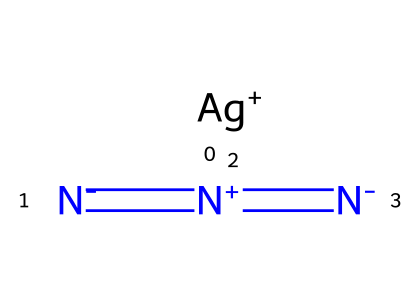What is the total number of nitrogen atoms in silver azide? The structure includes three nitrogen atoms in its formula. Each nitrogen atom is explicitly represented in the SMILES notation.
Answer: three How many bonds are present in the silver azide molecule? Analyzing the structure, there is one bond between silver and nitrogen, and two bonds between the nitrogen atoms. Adding these gives a total of three bonds.
Answer: three What is the primary function of silver azide in photographic film development? Silver azide acts as a light-sensitive compound, which is responsible for creating images in photographic processes.
Answer: light-sensitive Which type of chemical is silver azide classified as? Silver azide belongs to the azide family, characterized by the presence of the azide group (N3).
Answer: azide What charge does the silver ion carry in silver azide? The silver ion is represented as Ag+ in the structure, indicating that it has a positive charge.
Answer: positive What is the oxidation state of nitrogen in silver azide? The nitrogen atoms in the azide group typically have an average oxidation state of -1 each, as indicated by the structure and the overall charge.
Answer: -1 How is silver azide different from typical halides? Unlike halides, which are salts of halogen ions, silver azide is formed with the azide group, which contains more nitrogen than typical halide compounds.
Answer: distinct composition 